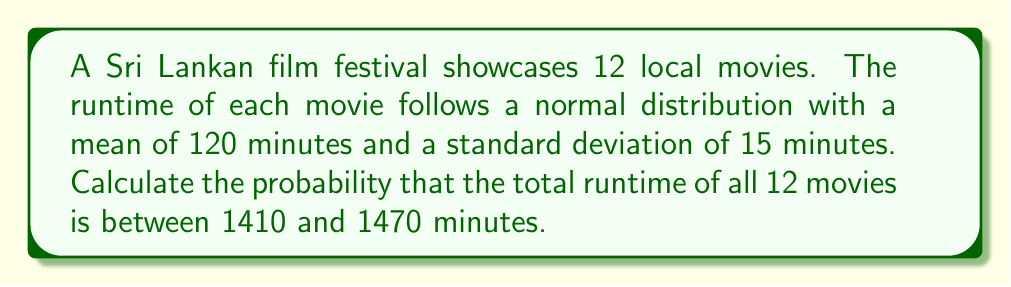Could you help me with this problem? Let's approach this step-by-step:

1) First, we need to find the mean and standard deviation of the total runtime for 12 movies.

   Mean of total runtime: $\mu_{total} = 12 \times 120 = 1440$ minutes
   
   Variance of total runtime: $\sigma^2_{total} = 12 \times 15^2 = 2700$ minutes^2
   
   Standard deviation of total runtime: $\sigma_{total} = \sqrt{2700} = 51.96$ minutes

2) Now, we need to standardize the given range:

   Lower bound: $z_1 = \frac{1410 - 1440}{51.96} = -0.577$
   Upper bound: $z_2 = \frac{1470 - 1440}{51.96} = 0.577$

3) The probability is the area under the standard normal curve between these z-scores:

   $P(-0.577 < Z < 0.577)$

4) Using a standard normal table or calculator:

   $P(Z < 0.577) - P(Z < -0.577) = 0.7180 - 0.2820 = 0.4360$

Therefore, the probability that the total runtime is between 1410 and 1470 minutes is approximately 0.4360 or 43.60%.
Answer: 0.4360 